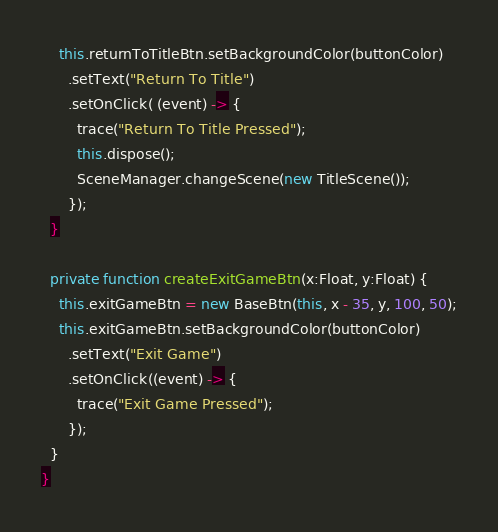<code> <loc_0><loc_0><loc_500><loc_500><_Haxe_>    this.returnToTitleBtn.setBackgroundColor(buttonColor)
      .setText("Return To Title")
      .setOnClick( (event) -> {
        trace("Return To Title Pressed");
        this.dispose();
        SceneManager.changeScene(new TitleScene());
      });
  }

  private function createExitGameBtn(x:Float, y:Float) {
    this.exitGameBtn = new BaseBtn(this, x - 35, y, 100, 50);
    this.exitGameBtn.setBackgroundColor(buttonColor)
      .setText("Exit Game")
      .setOnClick((event) -> {
        trace("Exit Game Pressed");
      });
  }
}</code> 